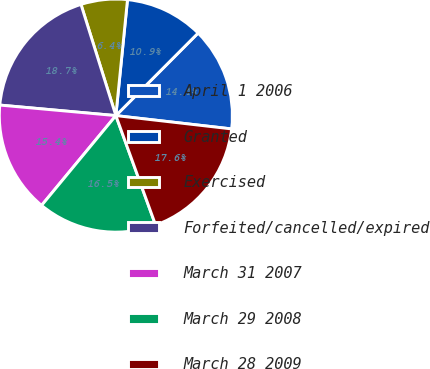Convert chart. <chart><loc_0><loc_0><loc_500><loc_500><pie_chart><fcel>April 1 2006<fcel>Granted<fcel>Exercised<fcel>Forfeited/cancelled/expired<fcel>March 31 2007<fcel>March 29 2008<fcel>March 28 2009<nl><fcel>14.35%<fcel>10.88%<fcel>6.43%<fcel>18.72%<fcel>15.44%<fcel>16.54%<fcel>17.63%<nl></chart> 